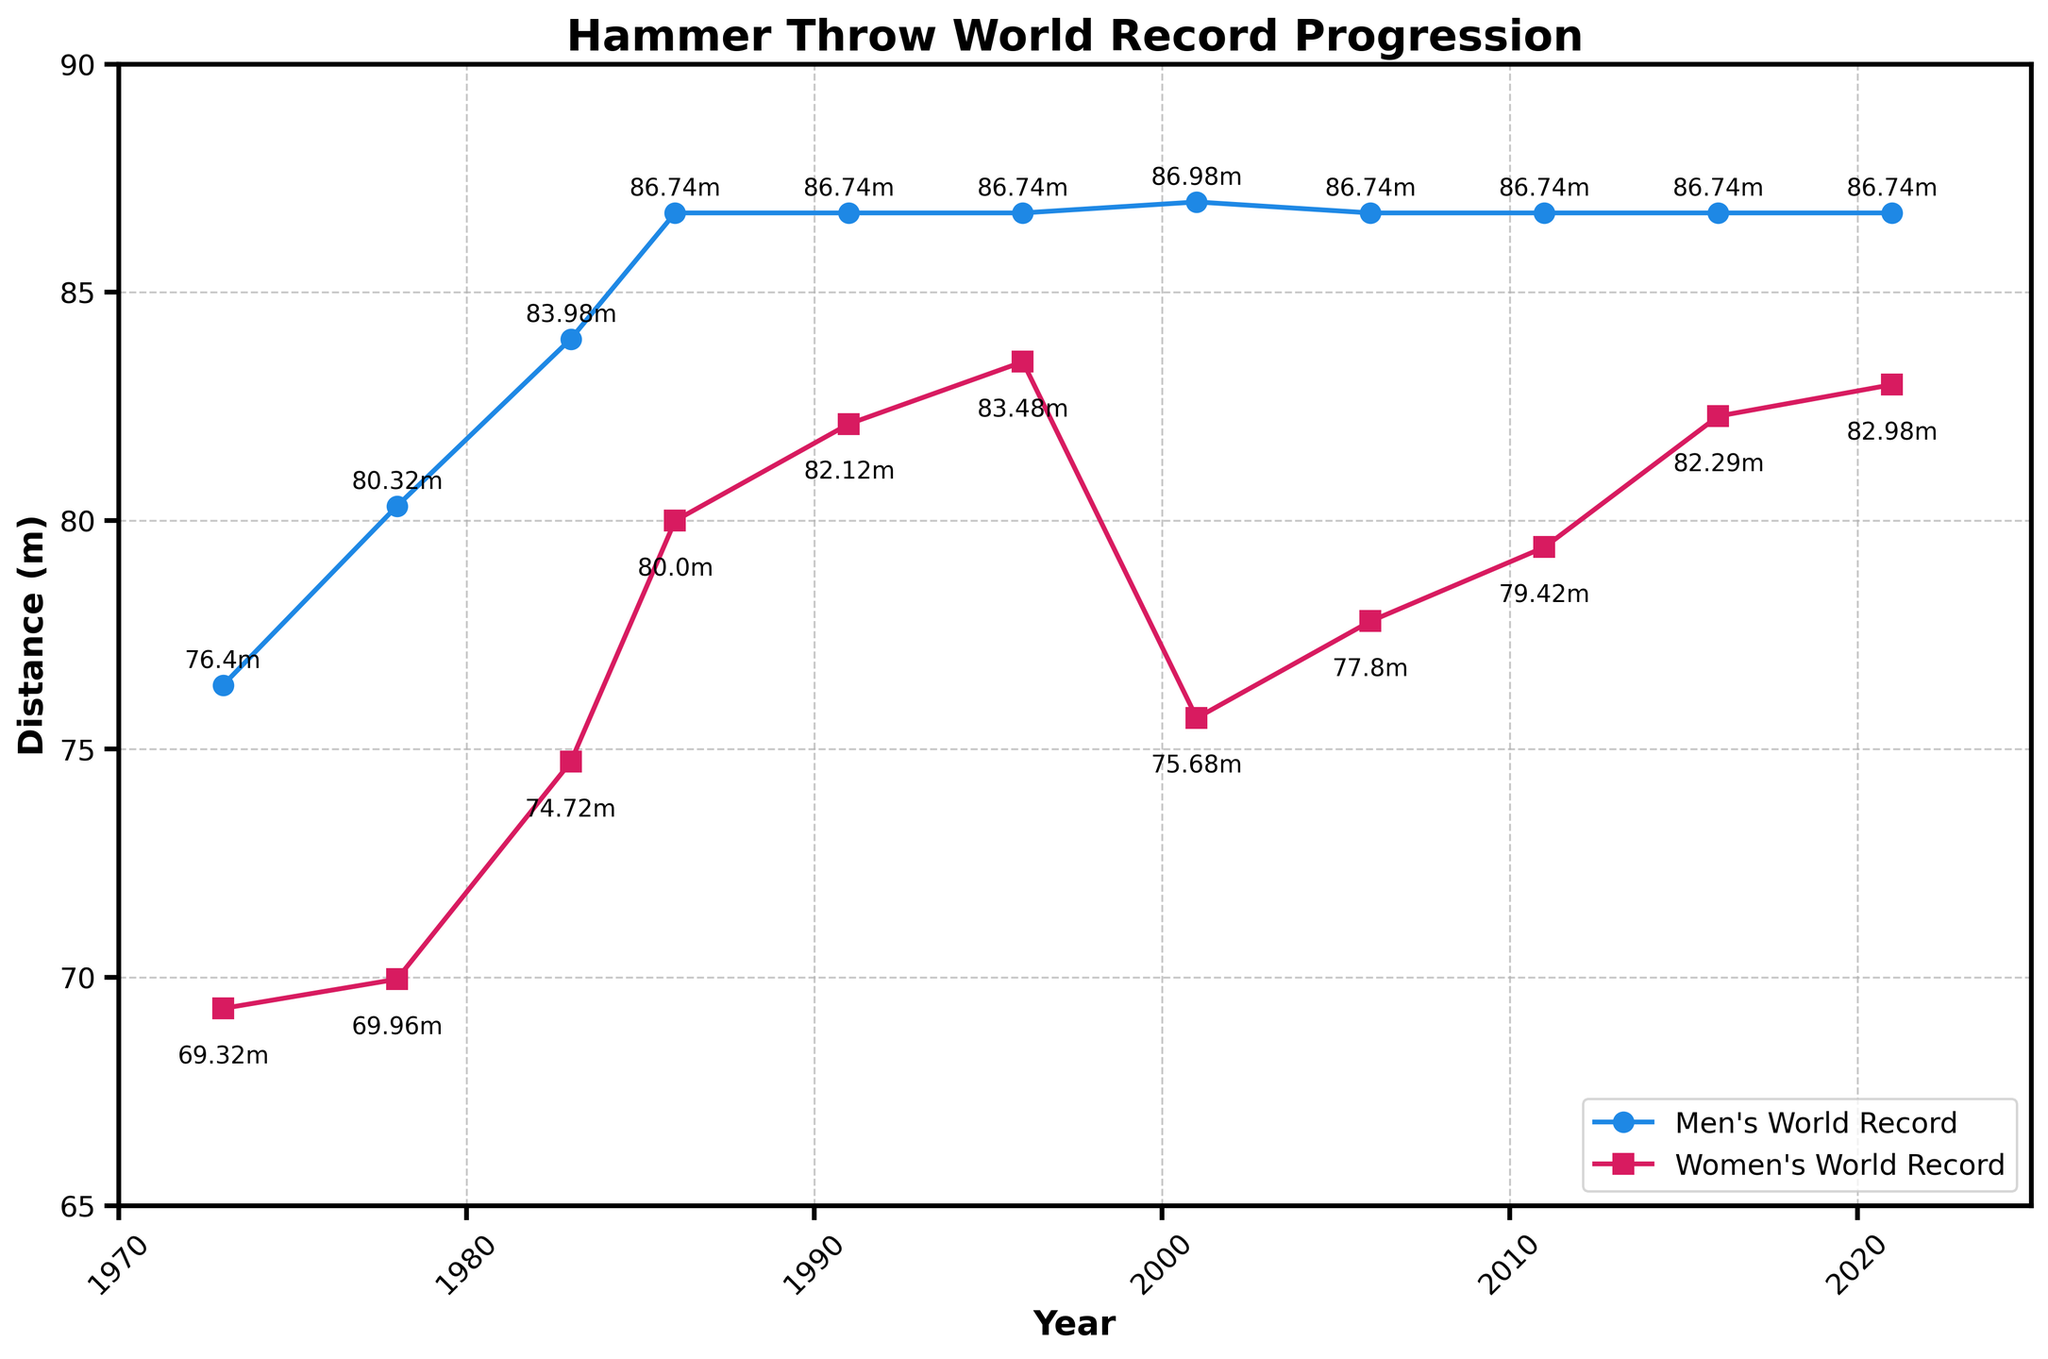What year did the Men's World Record hit 80 meters for the first time? The Men's World Record reached 80.32 meters in the year 1978, as shown by the data point for this year.
Answer: 1978 By how much did the Women's World Record improve from 1973 to 2021? To find the improvement, subtract the record in 1973 from the record in 2021. The Women's record in 1973 was 69.32m, and in 2021 it was 82.98m. So, 82.98 - 69.32 = 13.66m.
Answer: 13.66m Which year saw a higher increase in the Women's World Record: 1983 or 1986? In 1983, the Women's World Record was 74.72m, and in 1986, it was 80m. So, the increase from 74.72m to 80m is 5.28m. The increase from 1978 (69.96m) to 1983 (74.72m) is 4.76m. 5.28m is higher than 4.76m.
Answer: 1986 How many years did the Men's World Record remain unchanged at 86.74 meters? The Men's World Record hit 86.74 meters in 1986 and stayed the same through 2021. So, 2021 - 1986 = 35 years.
Answer: 35 years Did the Women's World Record ever surpass 80 meters? Yes, the Women's World Record surpassed 80 meters for the first time in 1986 and has surpassed it in several years after that.
Answer: Yes Identify the color associated with the Men's World Record on the plot. The Men's World Record line is shown in blue on the plot.
Answer: Blue Compare the progression trends of Men's and Women's World Records from 1991 to 2021. The Men's World Record remained constant at 86.74 meters from 1991 to 2021. In contrast, the Women's World Record experienced an upward trend, increasing from 82.12 meters in 1991 to 82.98 meters in 2021.
Answer: Men's constant, Women's increasing What was the maximum distance achieved in the Women's World Record? The maximum distance achieved in the Women's World Record is 83.48 meters in the year 1996.
Answer: 83.48m 